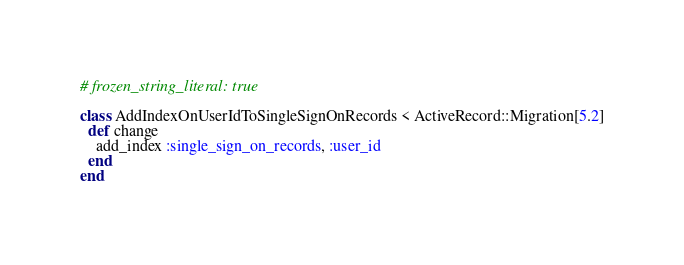<code> <loc_0><loc_0><loc_500><loc_500><_Ruby_># frozen_string_literal: true

class AddIndexOnUserIdToSingleSignOnRecords < ActiveRecord::Migration[5.2]
  def change
    add_index :single_sign_on_records, :user_id
  end
end
</code> 